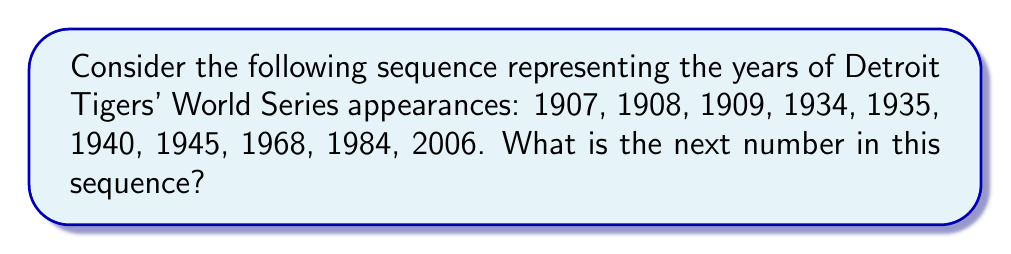Give your solution to this math problem. To find the next number in this sequence, we need to analyze the pattern of World Series appearances for the Detroit Tigers. Let's break it down step-by-step:

1) First, we'll calculate the differences between consecutive appearances:
   $$
   \begin{aligned}
   1908 - 1907 &= 1 \\
   1909 - 1908 &= 1 \\
   1934 - 1909 &= 25 \\
   1935 - 1934 &= 1 \\
   1940 - 1935 &= 5 \\
   1945 - 1940 &= 5 \\
   1968 - 1945 &= 23 \\
   1984 - 1968 &= 16 \\
   2006 - 1984 &= 22
   \end{aligned}
   $$

2) We can see that there's no consistent arithmetic or geometric progression. However, we can observe that the gaps between appearances have generally been increasing over time.

3) The most recent gap was 22 years (2006 - 1984 = 22).

4) Given the increasing trend in gaps and the team's recent performance (not making it to the World Series since 2006), we can estimate that the next appearance might occur after a similar or slightly larger gap.

5) Let's assume a gap of 23 years (one year more than the previous gap).

6) Therefore, the next World Series appearance can be estimated as:
   $$ 2006 + 23 = 2029 $$

While this is not a mathematically certain answer, it's a reasonable projection based on the historical pattern and recent trend.
Answer: 2029 